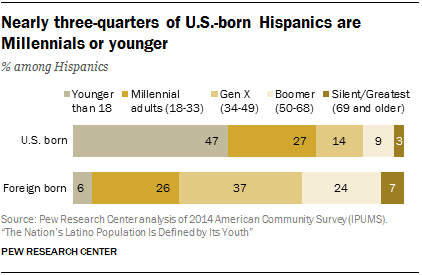Outline some significant characteristics in this image. The number of U.S.-born Hispanics who are Baby Boomers is lower than the number of those who are Millennials, at 0.18," according to the data. The value of the shortest bar in a set of n bars with a minimum length of 3 is unknown. 